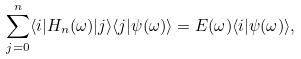<formula> <loc_0><loc_0><loc_500><loc_500>\sum _ { j = 0 } ^ { n } \langle i | H _ { n } ( \omega ) | j \rangle \langle j | \psi ( \omega ) \rangle = E ( \omega ) \langle i | \psi ( \omega ) \rangle ,</formula> 